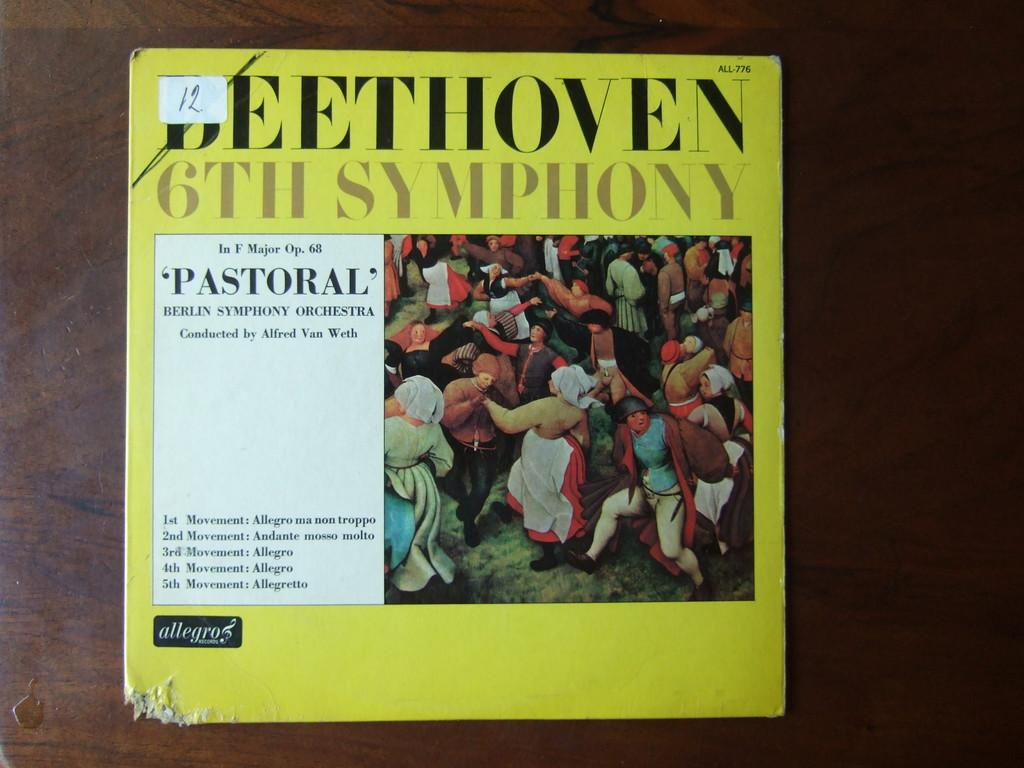<image>
Provide a brief description of the given image. A bright yellow record sleeve for Beethoven's 6th symphony features a crowd of Renaissance people on the cover. 